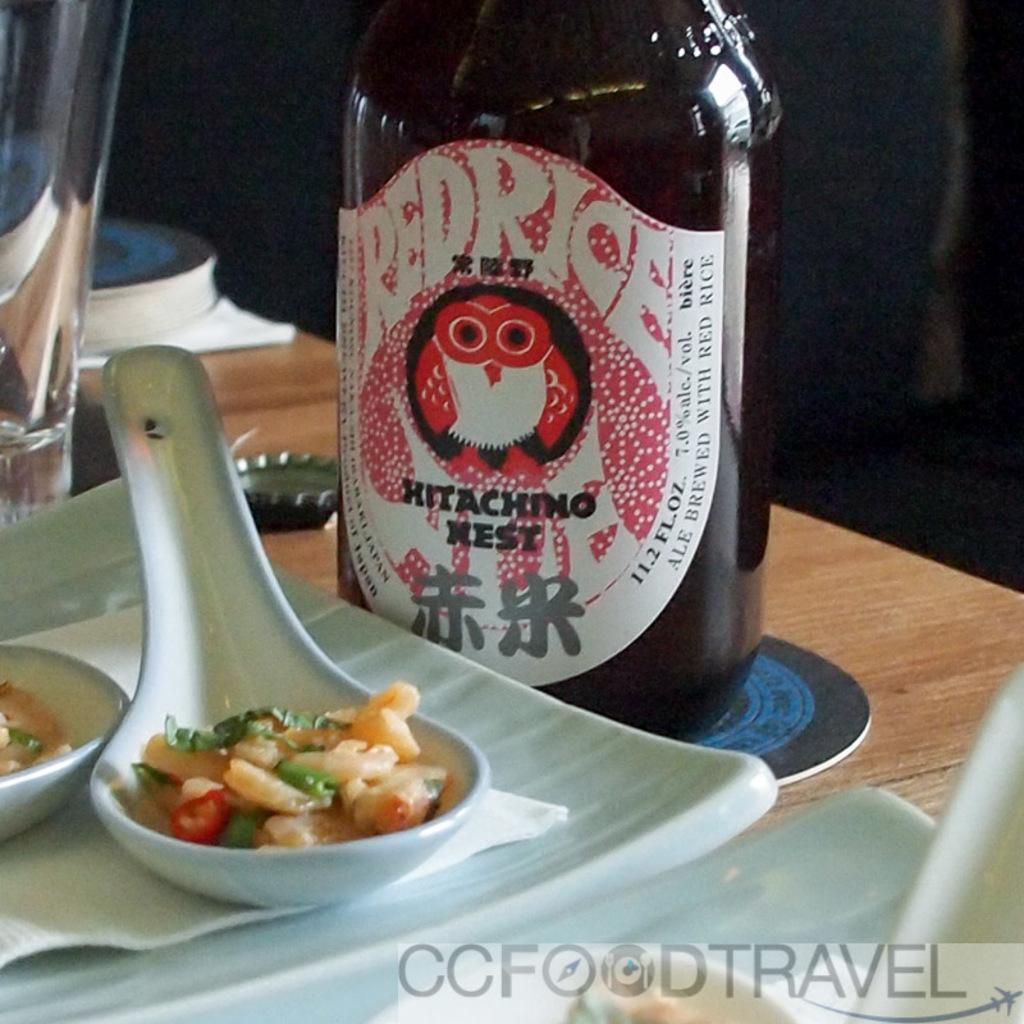<image>
Summarize the visual content of the image. A bottle of Red Rice wine next to a white plate of food. 